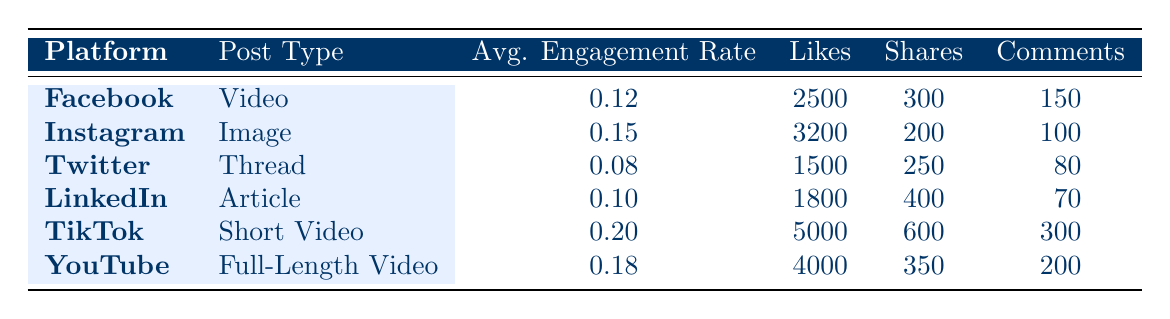What is the average engagement rate for TikTok? The table shows that TikTok has an average engagement rate of 0.20.
Answer: 0.20 Which platform had the highest number of likes? By comparing the "Likes" column, TikTok has the highest number of likes at 5000.
Answer: TikTok Is the average engagement rate for LinkedIn higher than that for Twitter? The average engagement rate for LinkedIn is 0.10 and for Twitter is 0.08, which means LinkedIn's engagement rate is higher.
Answer: Yes How many total likes were garnered across all platforms? Adding the likes: 2500 (Facebook) + 3200 (Instagram) + 1500 (Twitter) + 1800 (LinkedIn) + 5000 (TikTok) + 4000 (YouTube) = 18000 likes in total.
Answer: 18000 What is the average number of comments across all platforms listed? To find the average number of comments, sum the comments: 150 (Facebook) + 100 (Instagram) + 80 (Twitter) + 70 (LinkedIn) + 300 (TikTok) + 200 (YouTube) = 900. There are 6 platforms, so the average is 900/6 = 150.
Answer: 150 Is there a platform where the number of shares is equal to or greater than the number of comments? Looking at the shares and comments columns, TikTok has 600 shares and 300 comments, and LinkedIn has 400 shares and 70 comments. Both meet the condition, so the answer is yes.
Answer: Yes Which platform's post type yielded the least engagement rate? The engagement rates are 0.12 (Facebook), 0.15 (Instagram), 0.08 (Twitter), 0.10 (LinkedIn), 0.20 (TikTok), and 0.18 (YouTube). Twitter, with 0.08, has the least engagement rate.
Answer: Twitter What is the combined number of shares for Instagram and YouTube? Adding the shares of Instagram (200) and YouTube (350) gives 200 + 350 = 550 shares combined.
Answer: 550 Which platform has a post type that has both the highest likes and shares? TikTok has the highest likes (5000) and shares (600). No other platform exceeds this in both categories.
Answer: TikTok 